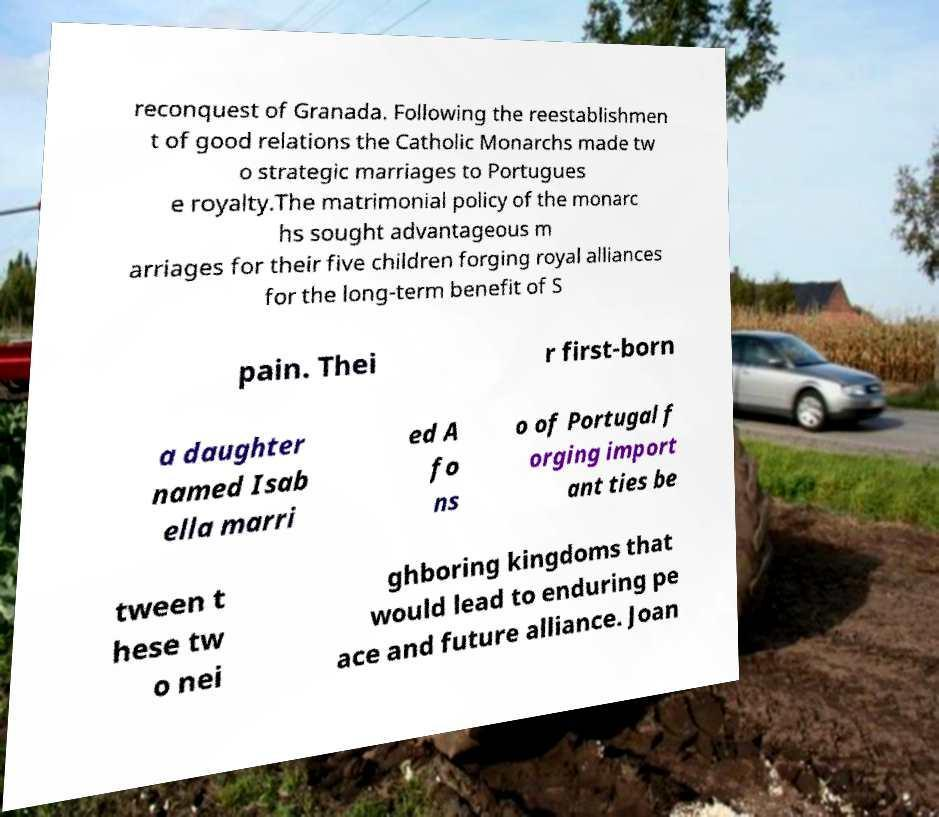There's text embedded in this image that I need extracted. Can you transcribe it verbatim? reconquest of Granada. Following the reestablishmen t of good relations the Catholic Monarchs made tw o strategic marriages to Portugues e royalty.The matrimonial policy of the monarc hs sought advantageous m arriages for their five children forging royal alliances for the long-term benefit of S pain. Thei r first-born a daughter named Isab ella marri ed A fo ns o of Portugal f orging import ant ties be tween t hese tw o nei ghboring kingdoms that would lead to enduring pe ace and future alliance. Joan 